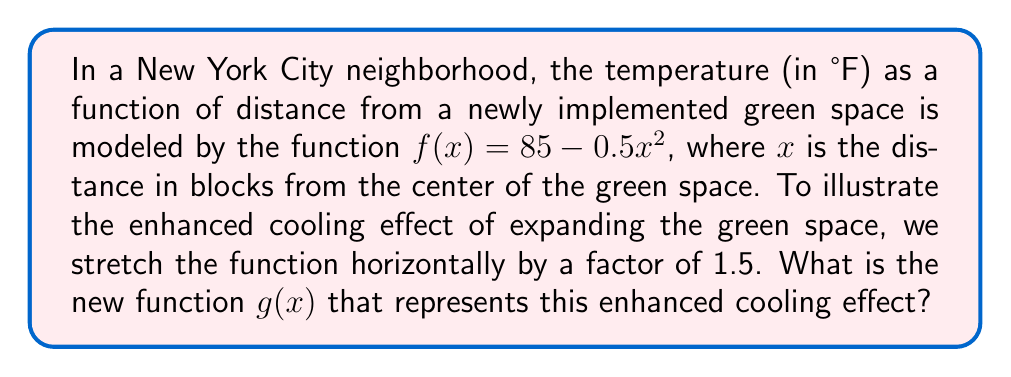Show me your answer to this math problem. To stretch a function horizontally by a factor of $k$, we replace $x$ with $\frac{x}{k}$ in the original function.

1. Original function: $f(x) = 85 - 0.5x^2$

2. Stretch factor: $k = 1.5$

3. Replace $x$ with $\frac{x}{1.5}$ in the original function:
   $g(x) = 85 - 0.5(\frac{x}{1.5})^2$

4. Simplify the expression inside the parentheses:
   $g(x) = 85 - 0.5(\frac{x^2}{2.25})$

5. Distribute the 0.5:
   $g(x) = 85 - \frac{0.5x^2}{2.25}$

6. Simplify the fraction:
   $g(x) = 85 - \frac{x^2}{4.5}$

This new function $g(x)$ represents the enhanced cooling effect of the expanded green space, showing a slower decrease in temperature as distance increases from the center.
Answer: $g(x) = 85 - \frac{x^2}{4.5}$ 